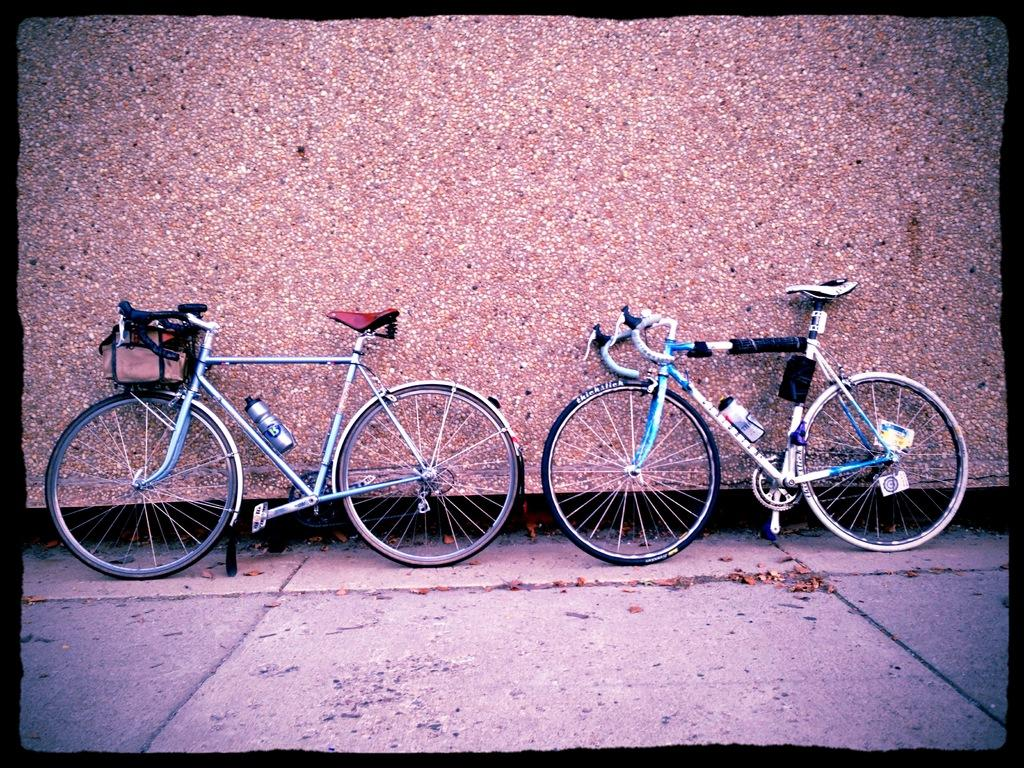How many bicycles are in the image? There are two bicycles in the image. What is the status of the bicycles in the image? The bicycles are parked. What is located behind the bicycles in the image? There is a wall behind the bicycles. What is the appearance of the wall in the image? The wall has stones on it. Who made the statement about the bicycles in the image? There is no statement made about the bicycles in the image, so it is not possible to identify an owner or speaker. 